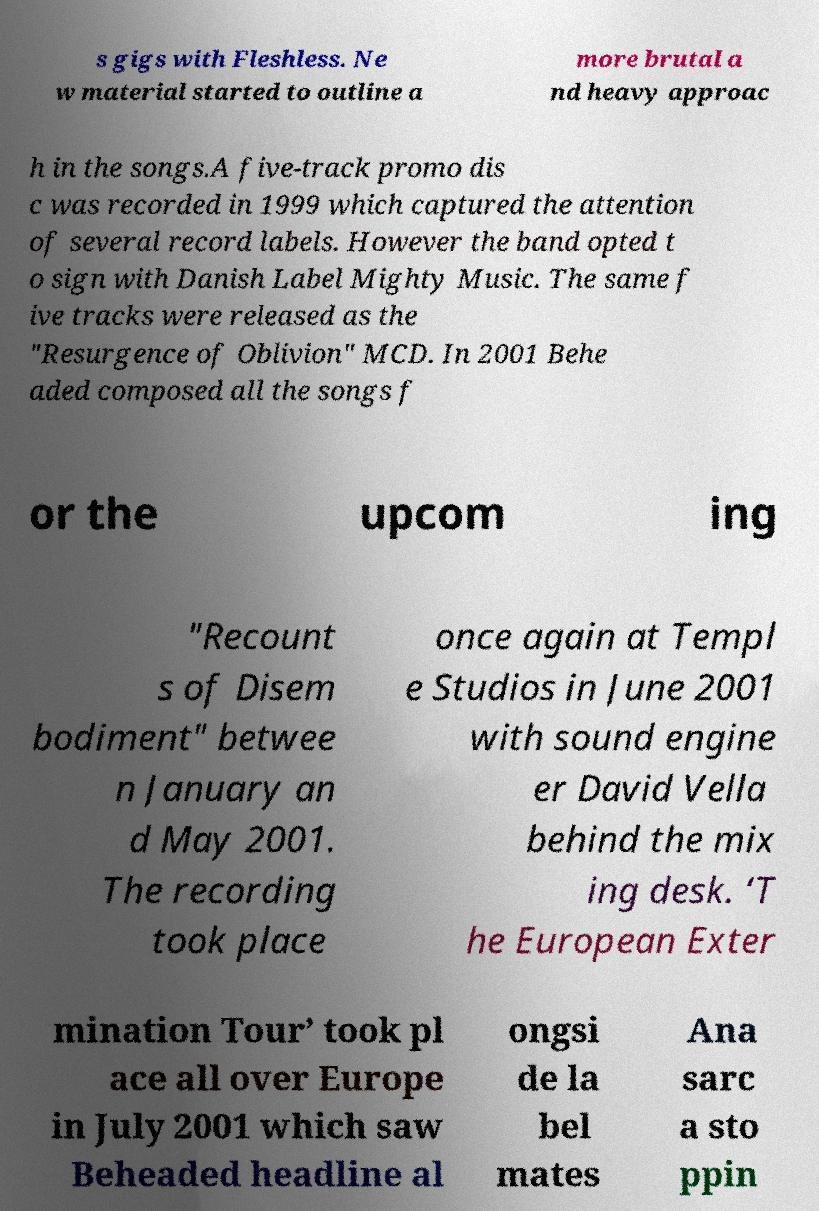Can you accurately transcribe the text from the provided image for me? s gigs with Fleshless. Ne w material started to outline a more brutal a nd heavy approac h in the songs.A five-track promo dis c was recorded in 1999 which captured the attention of several record labels. However the band opted t o sign with Danish Label Mighty Music. The same f ive tracks were released as the "Resurgence of Oblivion" MCD. In 2001 Behe aded composed all the songs f or the upcom ing "Recount s of Disem bodiment" betwee n January an d May 2001. The recording took place once again at Templ e Studios in June 2001 with sound engine er David Vella behind the mix ing desk. ‘T he European Exter mination Tour’ took pl ace all over Europe in July 2001 which saw Beheaded headline al ongsi de la bel mates Ana sarc a sto ppin 